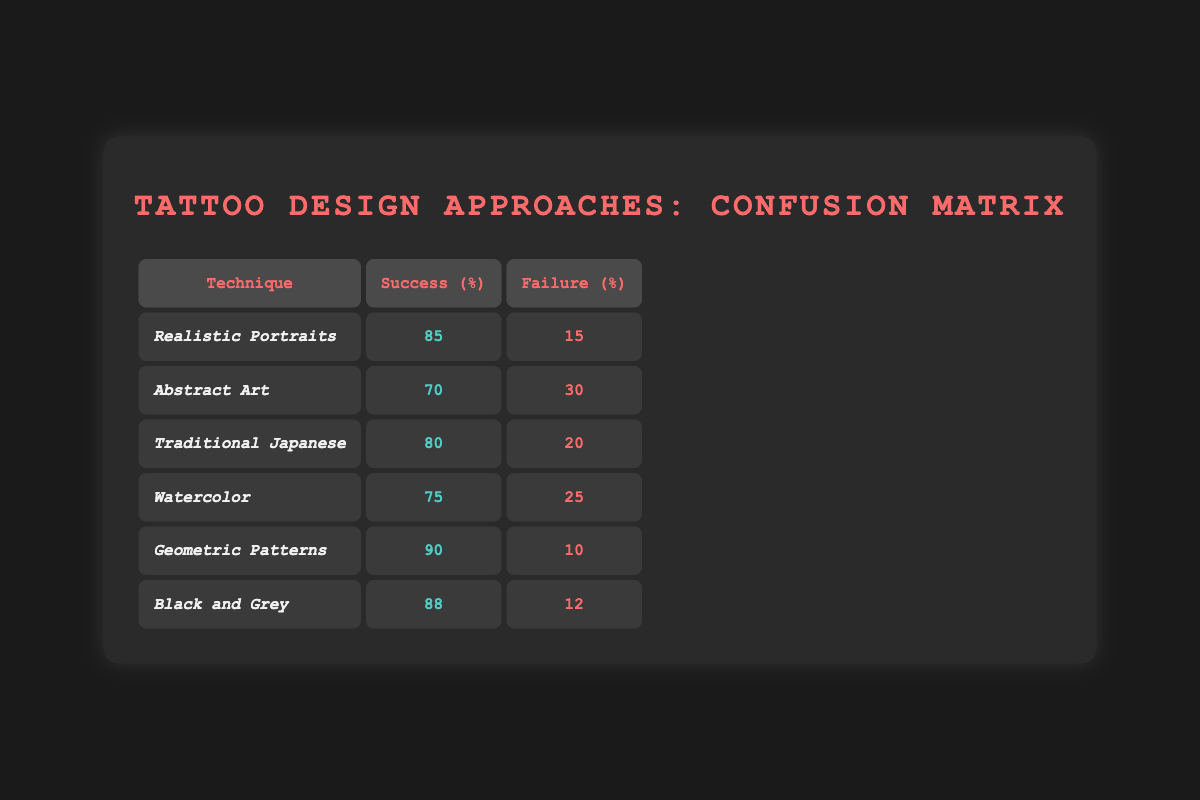What is the success percentage for Geometric Patterns? The table shows that the success percentage for Geometric Patterns is explicitly provided under the Success (%) column, which states 90.
Answer: 90 Which tattoo design technique has the highest failure rate? By examining the Failure (%) column, the technique with the highest failure rate is Abstract Art at 30.
Answer: Abstract Art What is the average success percentage across all tattoo design approaches? To calculate the average, add all success percentages: (85 + 70 + 80 + 75 + 90 + 88) = 488. There are 6 techniques, so divide 488 by 6, resulting in an average of 81.33.
Answer: 81.33 Is the success rate for Traditional Japanese higher than that for Watercolor? Comparing the Success (%) values, Traditional Japanese has a success rate of 80 while Watercolor's is 75. Since 80 is greater than 75, the answer is yes.
Answer: Yes What is the cumulative failure rate for Realistic Portraits and Black and Grey? The failure rate for Realistic Portraits is 15 and for Black and Grey it is 12. Adding these gives a cumulative failure rate of 15 + 12 = 27.
Answer: 27 Which two techniques have success percentages that are both above 85? Looking at the Success (%) column, the techniques that exceed 85 are Geometric Patterns at 90 and Black and Grey at 88.
Answer: Geometric Patterns and Black and Grey Is it true that the average failure rate for all techniques is below 20? Calculate the average failure rate: (15 + 30 + 20 + 25 + 10 + 12) = 112. Dividing by 6 gives an average of approximately 18.67, which is indeed below 20, so the statement is true.
Answer: True What is the difference in success rates between Black and Grey and Abstract Art? Black and Grey has a success rate of 88 and Abstract Art has 70. The difference is 88 - 70 = 18.
Answer: 18 